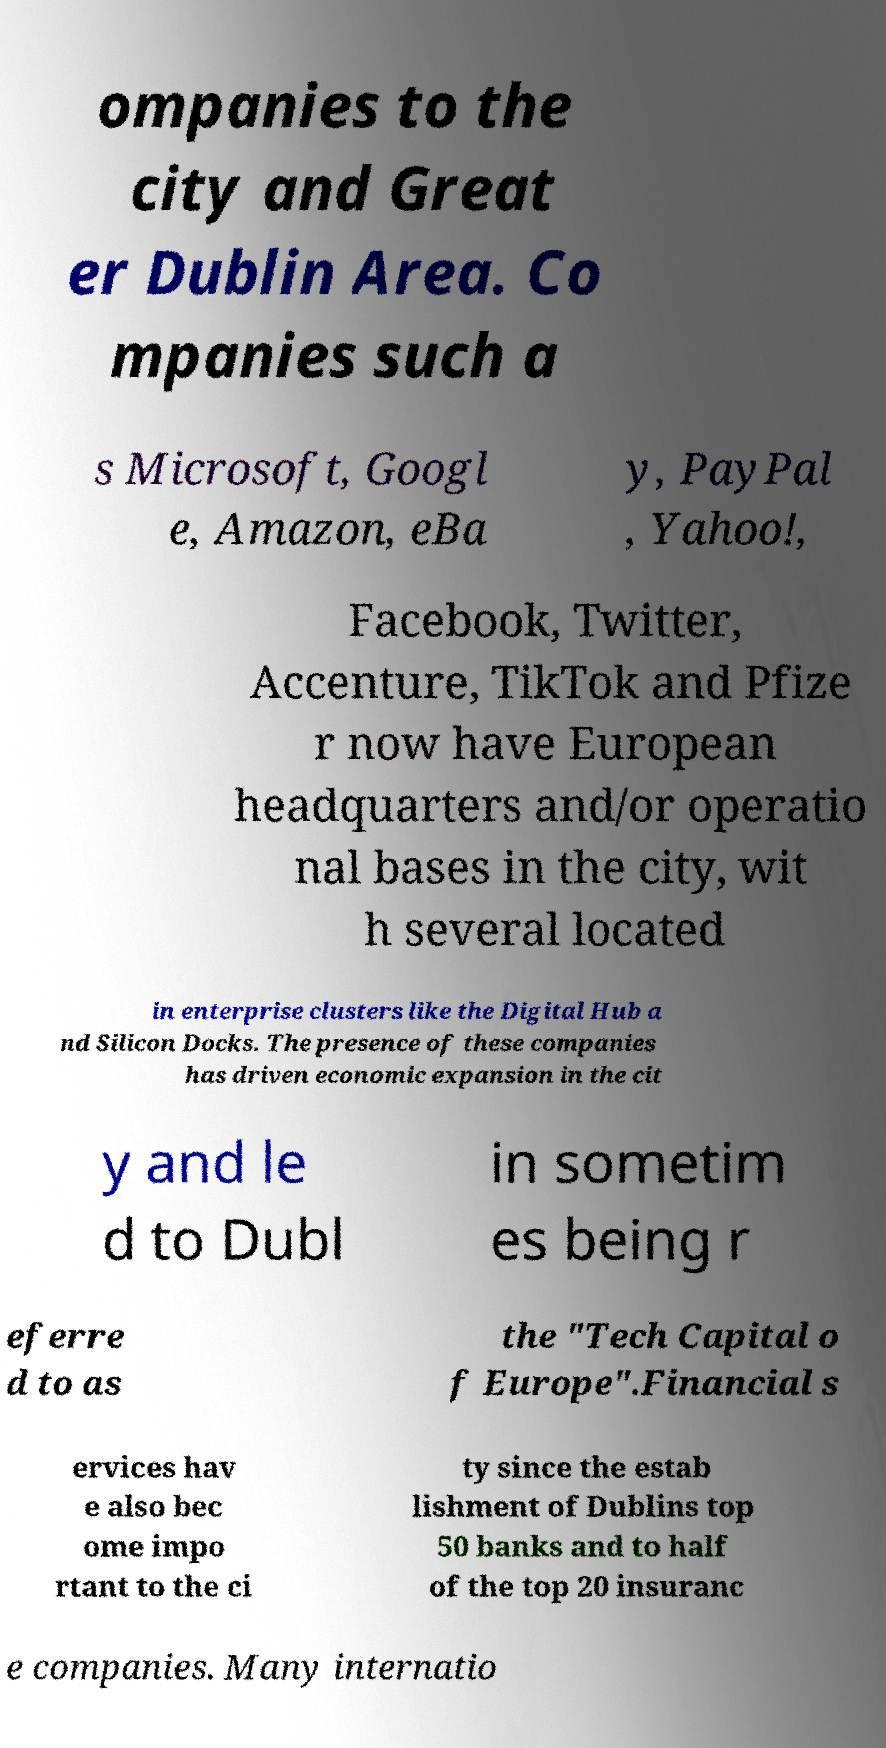What messages or text are displayed in this image? I need them in a readable, typed format. ompanies to the city and Great er Dublin Area. Co mpanies such a s Microsoft, Googl e, Amazon, eBa y, PayPal , Yahoo!, Facebook, Twitter, Accenture, TikTok and Pfize r now have European headquarters and/or operatio nal bases in the city, wit h several located in enterprise clusters like the Digital Hub a nd Silicon Docks. The presence of these companies has driven economic expansion in the cit y and le d to Dubl in sometim es being r eferre d to as the "Tech Capital o f Europe".Financial s ervices hav e also bec ome impo rtant to the ci ty since the estab lishment of Dublins top 50 banks and to half of the top 20 insuranc e companies. Many internatio 